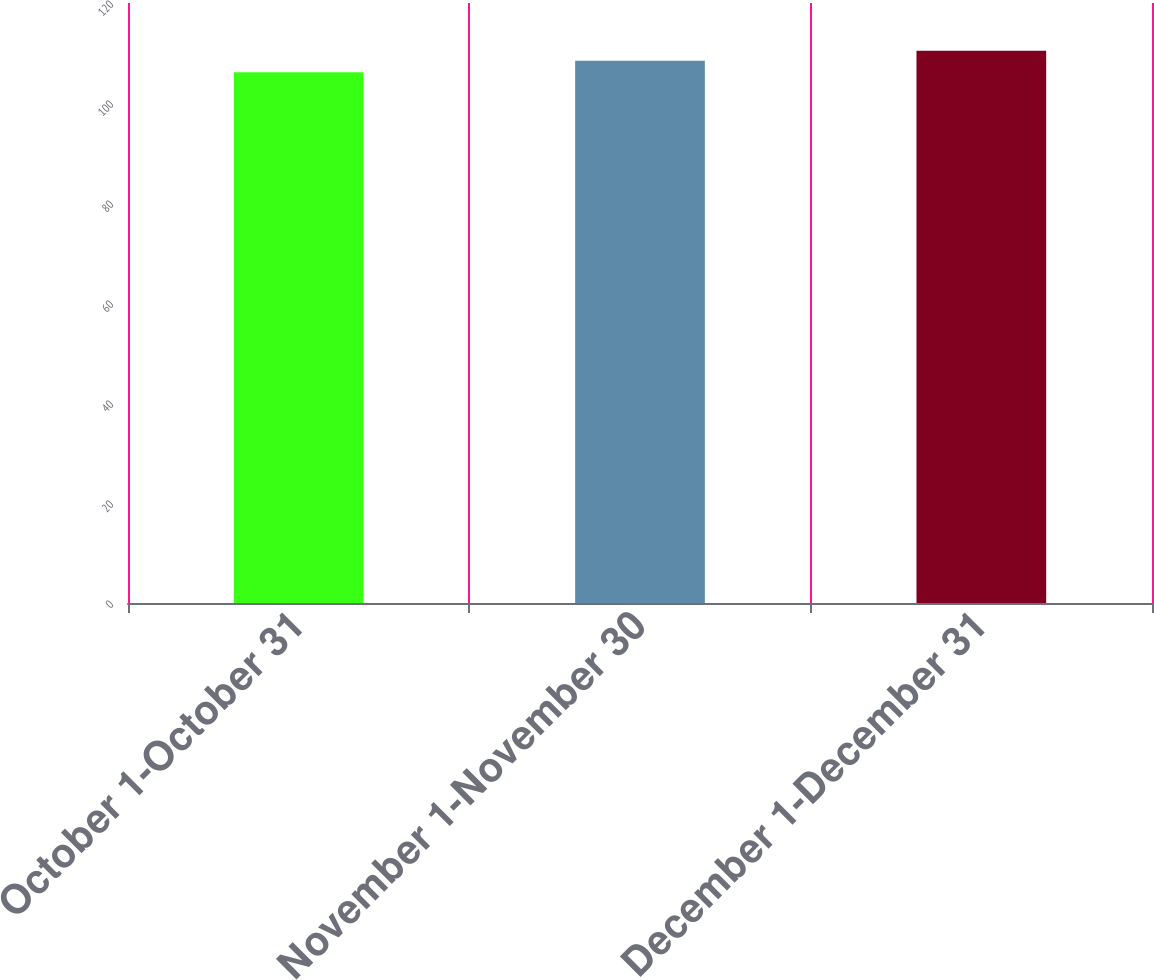Convert chart to OTSL. <chart><loc_0><loc_0><loc_500><loc_500><bar_chart><fcel>October 1-October 31<fcel>November 1-November 30<fcel>December 1-December 31<nl><fcel>106.17<fcel>108.43<fcel>110.45<nl></chart> 